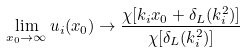Convert formula to latex. <formula><loc_0><loc_0><loc_500><loc_500>\lim _ { x _ { 0 } \rightarrow \infty } u _ { i } ( x _ { 0 } ) \rightarrow \frac { \chi [ k _ { i } x _ { 0 } + \delta _ { L } ( k _ { i } ^ { 2 } ) ] } { \chi [ \delta _ { L } ( k _ { i } ^ { 2 } ) ] }</formula> 